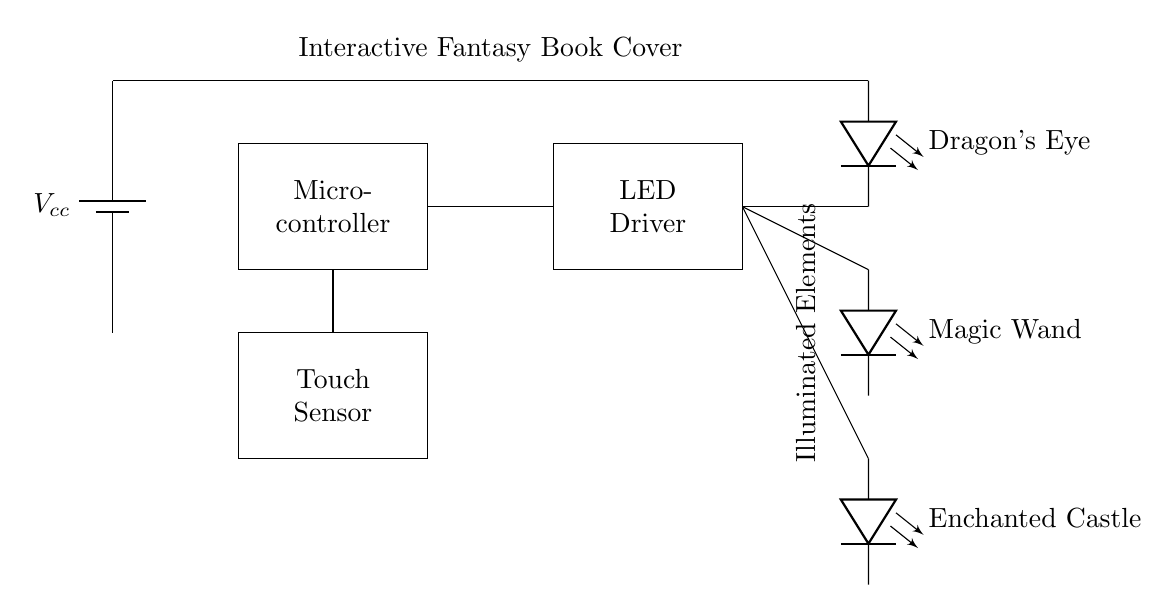What is the role of the microcontroller? The microcontroller processes input from the touch sensor and controls the LED driver based on that input, enabling the interactive functionality of the circuit.
Answer: Processing What components are powering this circuit? The circuit is powered by a battery, specifically labeled as Vcc, which supplies the necessary electrical energy for operation.
Answer: Battery How many illuminated elements are there in total? There are three illuminated elements, as indicated by the three LEDs connected in the circuit: Dragon's Eye, Magic Wand, and Enchanted Castle.
Answer: Three What component connects to the touch sensor? The microcontroller connects to the touch sensor, receiving input signals to trigger actions within the circuit.
Answer: Microcontroller Which component is responsible for driving the LEDs? The LED driver is responsible for supplying power and controlling the operation of the LEDs when activated by signals from the microcontroller.
Answer: LED Driver Why is it important for the microcontroller to interface with the touch sensor? The microcontroller processes the signals from the touch sensor to determine when to illuminate the connected LEDs, creating an interactive experience for the user.
Answer: Interaction 